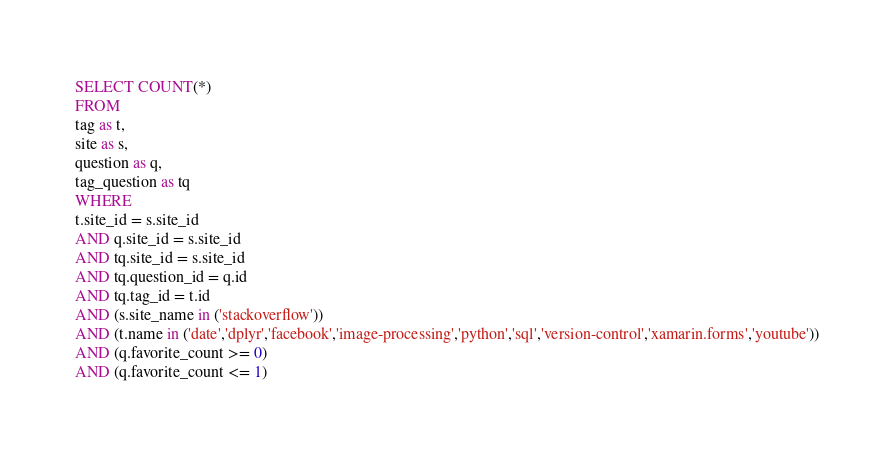<code> <loc_0><loc_0><loc_500><loc_500><_SQL_>SELECT COUNT(*)
FROM
tag as t,
site as s,
question as q,
tag_question as tq
WHERE
t.site_id = s.site_id
AND q.site_id = s.site_id
AND tq.site_id = s.site_id
AND tq.question_id = q.id
AND tq.tag_id = t.id
AND (s.site_name in ('stackoverflow'))
AND (t.name in ('date','dplyr','facebook','image-processing','python','sql','version-control','xamarin.forms','youtube'))
AND (q.favorite_count >= 0)
AND (q.favorite_count <= 1)
</code> 